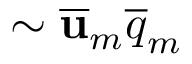Convert formula to latex. <formula><loc_0><loc_0><loc_500><loc_500>\sim \overline { u } _ { m } \overline { q } _ { m }</formula> 